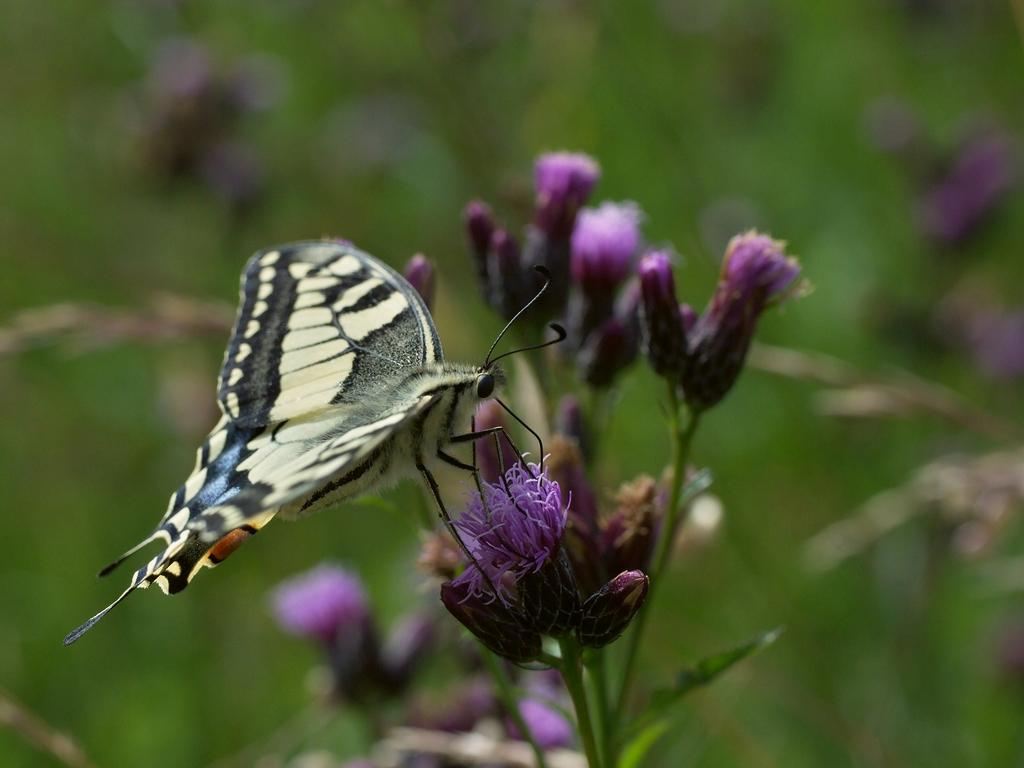What is the main subject of the image? There is a butterfly in the image. Where is the butterfly located in the image? The butterfly is sitting on a flower. Can you describe the background of the image? The background of the image is blurred. What type of power source is visible in the image? There is no power source visible in the image; it features a butterfly sitting on a flower with a blurred background. How many oranges can be seen in the image? There are no oranges present in the image. 